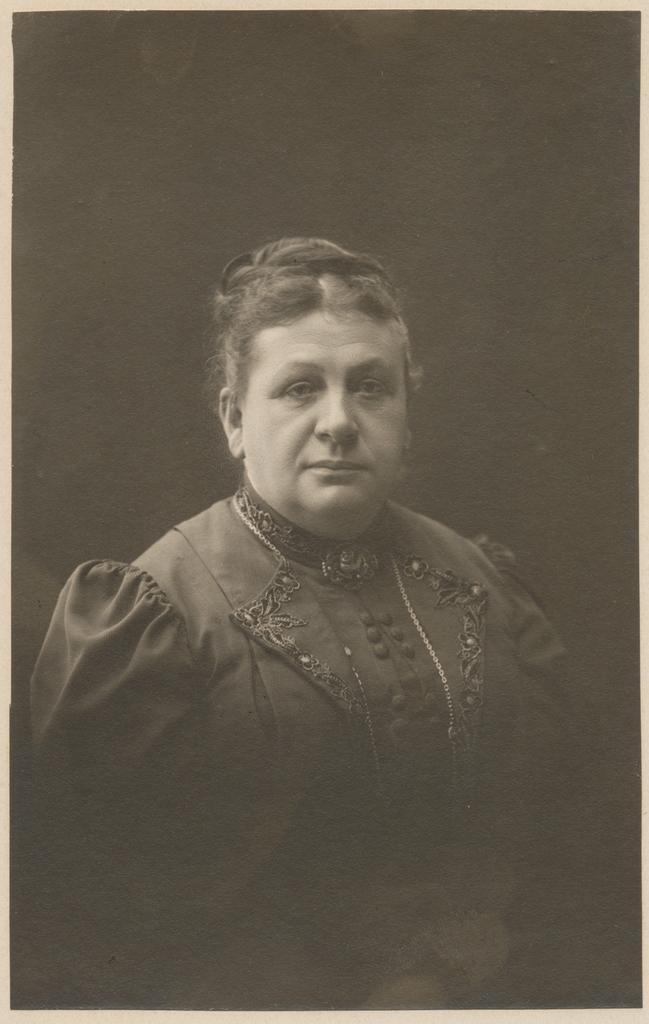Please provide a concise description of this image. This is a black and white picture of a woman and she wore a dress. 